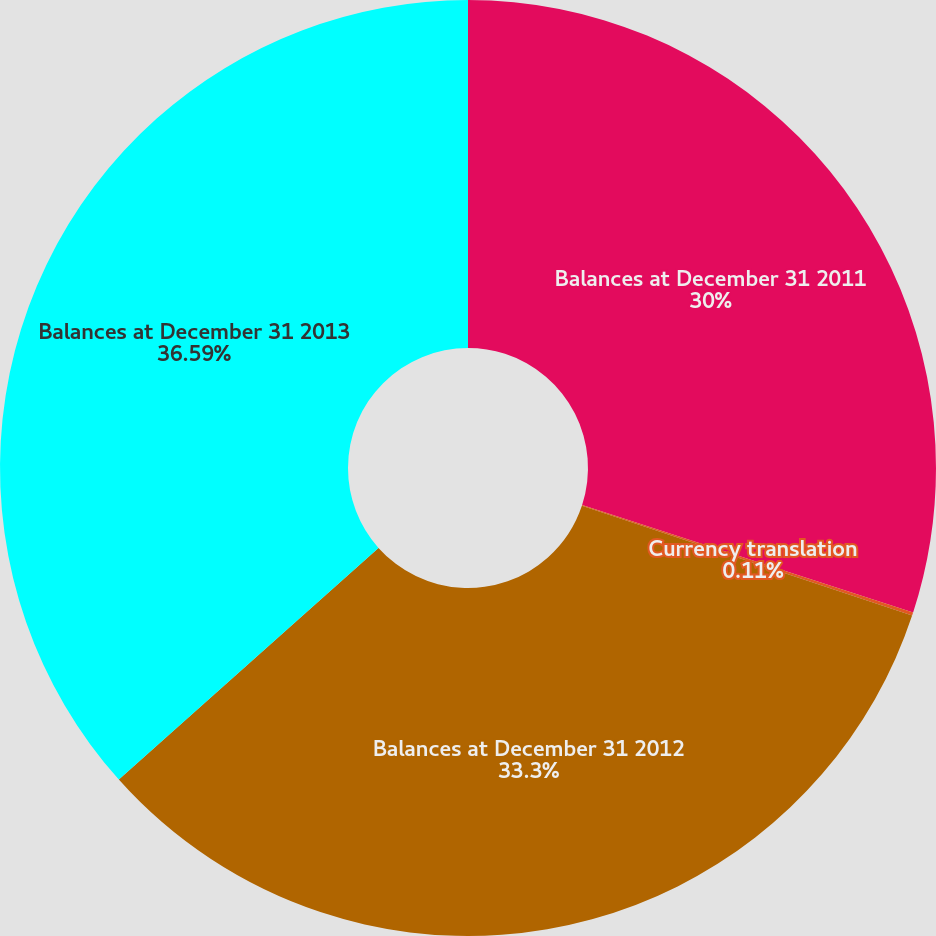<chart> <loc_0><loc_0><loc_500><loc_500><pie_chart><fcel>Balances at December 31 2011<fcel>Currency translation<fcel>Balances at December 31 2012<fcel>Balances at December 31 2013<nl><fcel>30.0%<fcel>0.11%<fcel>33.3%<fcel>36.6%<nl></chart> 